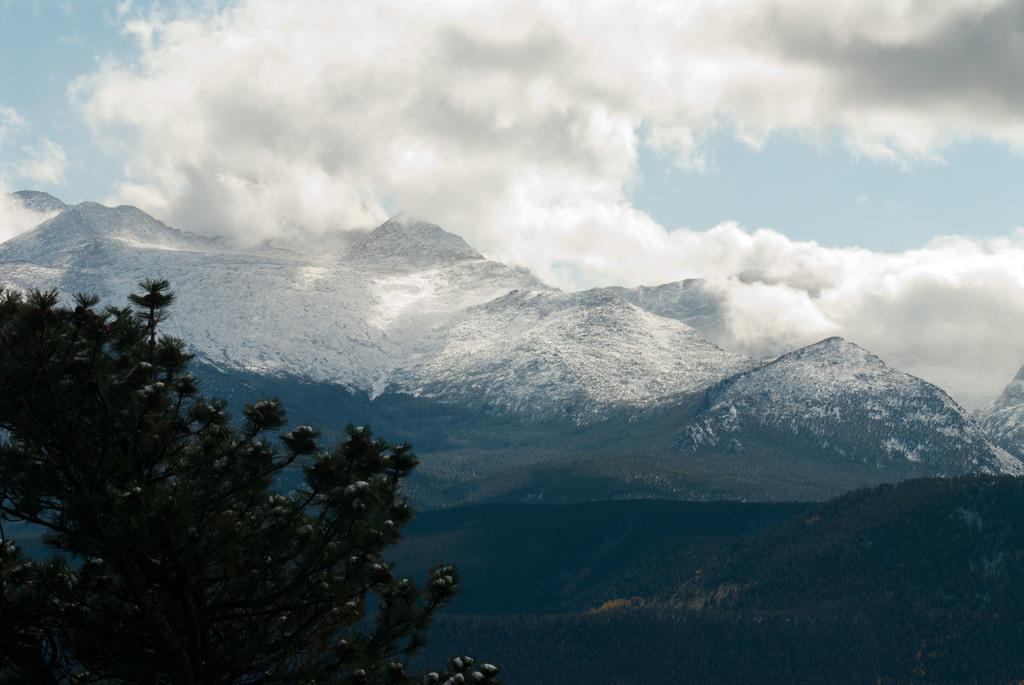What type of natural feature can be seen in the image? There is a tree and a mountain in the image. What is the condition of the sky in the image? The sky is cloudy in the image. What type of weather condition is suggested by the presence of snow in the image? The presence of snow suggests cold weather. What type of acoustics can be heard in the image? There is no sound or acoustics present in the image, as it is a still photograph. What season is depicted in the image? The presence of snow suggests that the image may depict winter, but the season cannot be definitively determined from the image alone. 